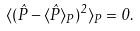<formula> <loc_0><loc_0><loc_500><loc_500>\langle ( \hat { P } - \langle \hat { P } \rangle _ { P } ) ^ { 2 } \rangle _ { P } = 0 .</formula> 